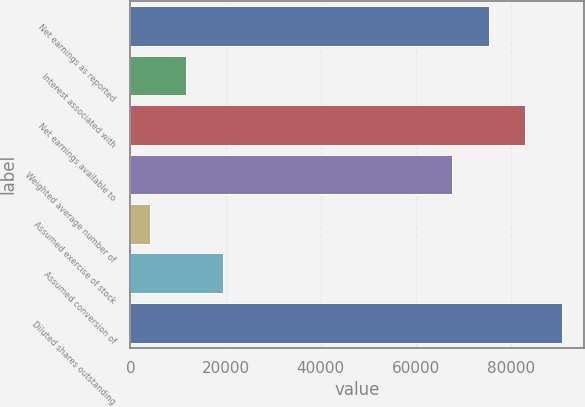Convert chart to OTSL. <chart><loc_0><loc_0><loc_500><loc_500><bar_chart><fcel>Net earnings as reported<fcel>Interest associated with<fcel>Net earnings available to<fcel>Weighted average number of<fcel>Assumed exercise of stock<fcel>Assumed conversion of<fcel>Diluted shares outstanding<nl><fcel>75268.9<fcel>11781.9<fcel>82971.8<fcel>67566<fcel>4079<fcel>19484.8<fcel>90674.7<nl></chart> 